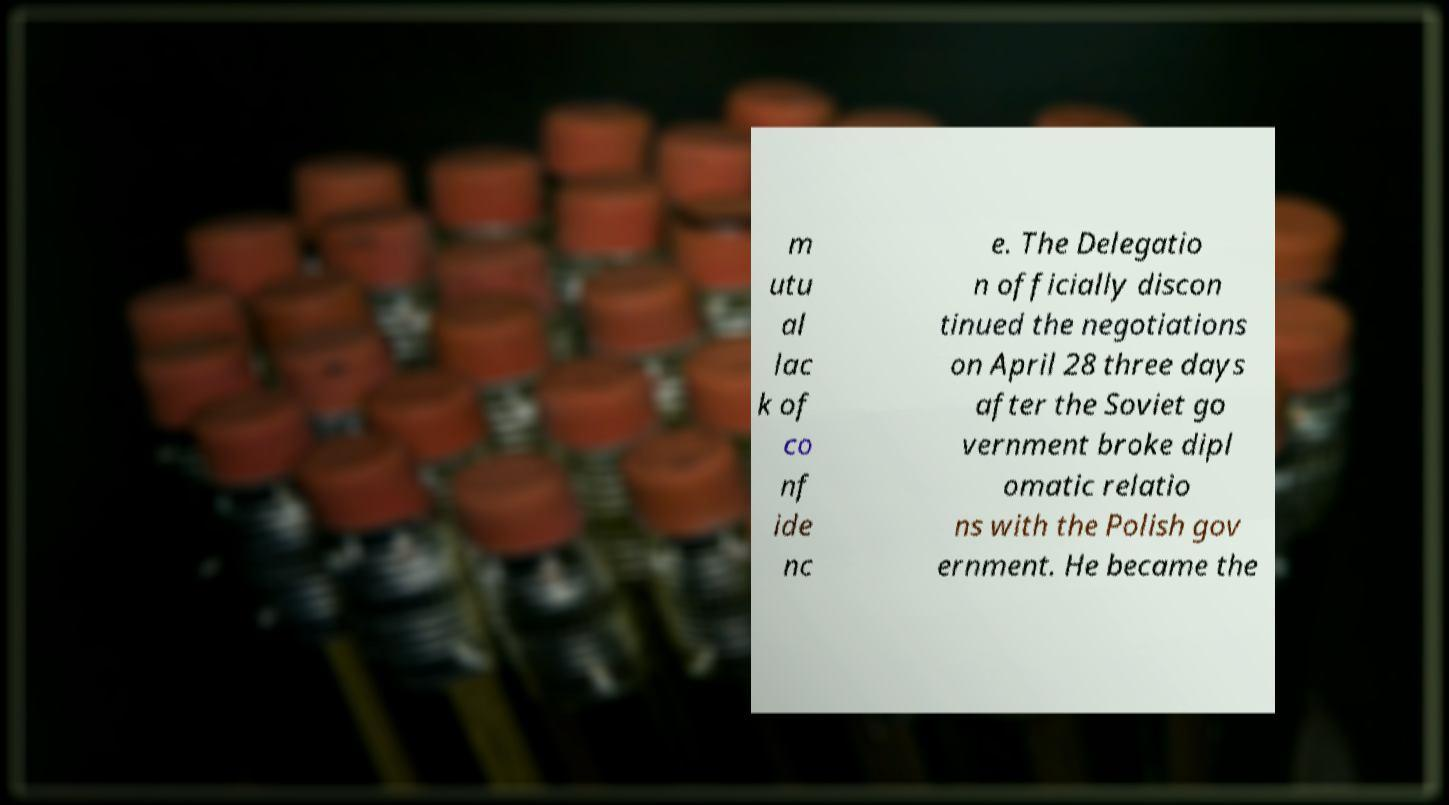Can you accurately transcribe the text from the provided image for me? m utu al lac k of co nf ide nc e. The Delegatio n officially discon tinued the negotiations on April 28 three days after the Soviet go vernment broke dipl omatic relatio ns with the Polish gov ernment. He became the 